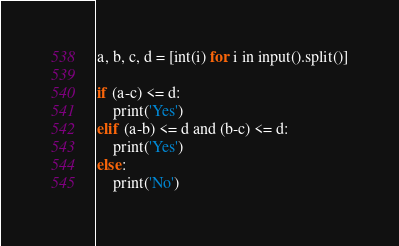<code> <loc_0><loc_0><loc_500><loc_500><_Python_>a, b, c, d = [int(i) for i in input().split()]

if (a-c) <= d:
    print('Yes')
elif (a-b) <= d and (b-c) <= d:
    print('Yes')
else:
    print('No')</code> 